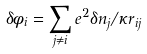Convert formula to latex. <formula><loc_0><loc_0><loc_500><loc_500>\delta \phi _ { i } = \sum _ { j \ne i } e ^ { 2 } \delta n _ { j } / \kappa r _ { i j }</formula> 